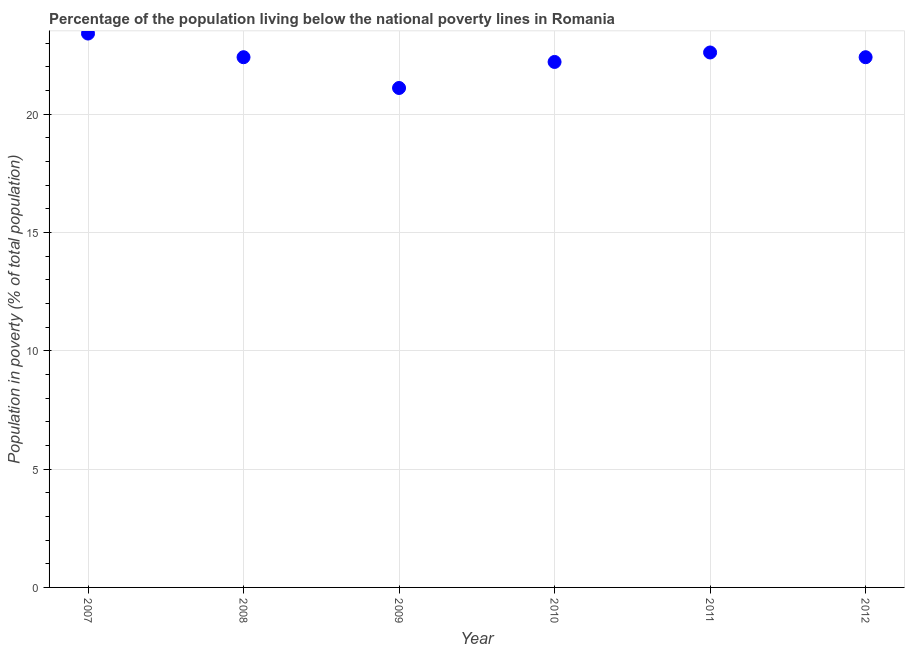What is the percentage of population living below poverty line in 2012?
Give a very brief answer. 22.4. Across all years, what is the maximum percentage of population living below poverty line?
Offer a very short reply. 23.4. Across all years, what is the minimum percentage of population living below poverty line?
Your response must be concise. 21.1. In which year was the percentage of population living below poverty line maximum?
Your response must be concise. 2007. What is the sum of the percentage of population living below poverty line?
Your answer should be very brief. 134.1. What is the average percentage of population living below poverty line per year?
Your answer should be compact. 22.35. What is the median percentage of population living below poverty line?
Make the answer very short. 22.4. In how many years, is the percentage of population living below poverty line greater than 16 %?
Offer a very short reply. 6. Do a majority of the years between 2009 and 2007 (inclusive) have percentage of population living below poverty line greater than 11 %?
Provide a succinct answer. No. What is the ratio of the percentage of population living below poverty line in 2007 to that in 2010?
Your answer should be compact. 1.05. Is the percentage of population living below poverty line in 2011 less than that in 2012?
Your answer should be very brief. No. What is the difference between the highest and the second highest percentage of population living below poverty line?
Your answer should be compact. 0.8. Is the sum of the percentage of population living below poverty line in 2010 and 2012 greater than the maximum percentage of population living below poverty line across all years?
Provide a short and direct response. Yes. What is the difference between the highest and the lowest percentage of population living below poverty line?
Your response must be concise. 2.3. In how many years, is the percentage of population living below poverty line greater than the average percentage of population living below poverty line taken over all years?
Your answer should be very brief. 4. Does the percentage of population living below poverty line monotonically increase over the years?
Your response must be concise. No. Does the graph contain any zero values?
Make the answer very short. No. Does the graph contain grids?
Your response must be concise. Yes. What is the title of the graph?
Your response must be concise. Percentage of the population living below the national poverty lines in Romania. What is the label or title of the Y-axis?
Keep it short and to the point. Population in poverty (% of total population). What is the Population in poverty (% of total population) in 2007?
Make the answer very short. 23.4. What is the Population in poverty (% of total population) in 2008?
Your response must be concise. 22.4. What is the Population in poverty (% of total population) in 2009?
Ensure brevity in your answer.  21.1. What is the Population in poverty (% of total population) in 2010?
Give a very brief answer. 22.2. What is the Population in poverty (% of total population) in 2011?
Make the answer very short. 22.6. What is the Population in poverty (% of total population) in 2012?
Provide a succinct answer. 22.4. What is the difference between the Population in poverty (% of total population) in 2007 and 2009?
Keep it short and to the point. 2.3. What is the difference between the Population in poverty (% of total population) in 2007 and 2011?
Provide a short and direct response. 0.8. What is the difference between the Population in poverty (% of total population) in 2007 and 2012?
Give a very brief answer. 1. What is the difference between the Population in poverty (% of total population) in 2008 and 2010?
Ensure brevity in your answer.  0.2. What is the difference between the Population in poverty (% of total population) in 2008 and 2011?
Make the answer very short. -0.2. What is the difference between the Population in poverty (% of total population) in 2008 and 2012?
Your answer should be compact. 0. What is the difference between the Population in poverty (% of total population) in 2009 and 2012?
Give a very brief answer. -1.3. What is the difference between the Population in poverty (% of total population) in 2010 and 2011?
Offer a terse response. -0.4. What is the difference between the Population in poverty (% of total population) in 2011 and 2012?
Offer a very short reply. 0.2. What is the ratio of the Population in poverty (% of total population) in 2007 to that in 2008?
Give a very brief answer. 1.04. What is the ratio of the Population in poverty (% of total population) in 2007 to that in 2009?
Offer a very short reply. 1.11. What is the ratio of the Population in poverty (% of total population) in 2007 to that in 2010?
Ensure brevity in your answer.  1.05. What is the ratio of the Population in poverty (% of total population) in 2007 to that in 2011?
Offer a very short reply. 1.03. What is the ratio of the Population in poverty (% of total population) in 2007 to that in 2012?
Your answer should be compact. 1.04. What is the ratio of the Population in poverty (% of total population) in 2008 to that in 2009?
Give a very brief answer. 1.06. What is the ratio of the Population in poverty (% of total population) in 2008 to that in 2010?
Your response must be concise. 1.01. What is the ratio of the Population in poverty (% of total population) in 2009 to that in 2011?
Provide a short and direct response. 0.93. What is the ratio of the Population in poverty (% of total population) in 2009 to that in 2012?
Your response must be concise. 0.94. What is the ratio of the Population in poverty (% of total population) in 2010 to that in 2011?
Give a very brief answer. 0.98. What is the ratio of the Population in poverty (% of total population) in 2010 to that in 2012?
Give a very brief answer. 0.99. What is the ratio of the Population in poverty (% of total population) in 2011 to that in 2012?
Keep it short and to the point. 1.01. 